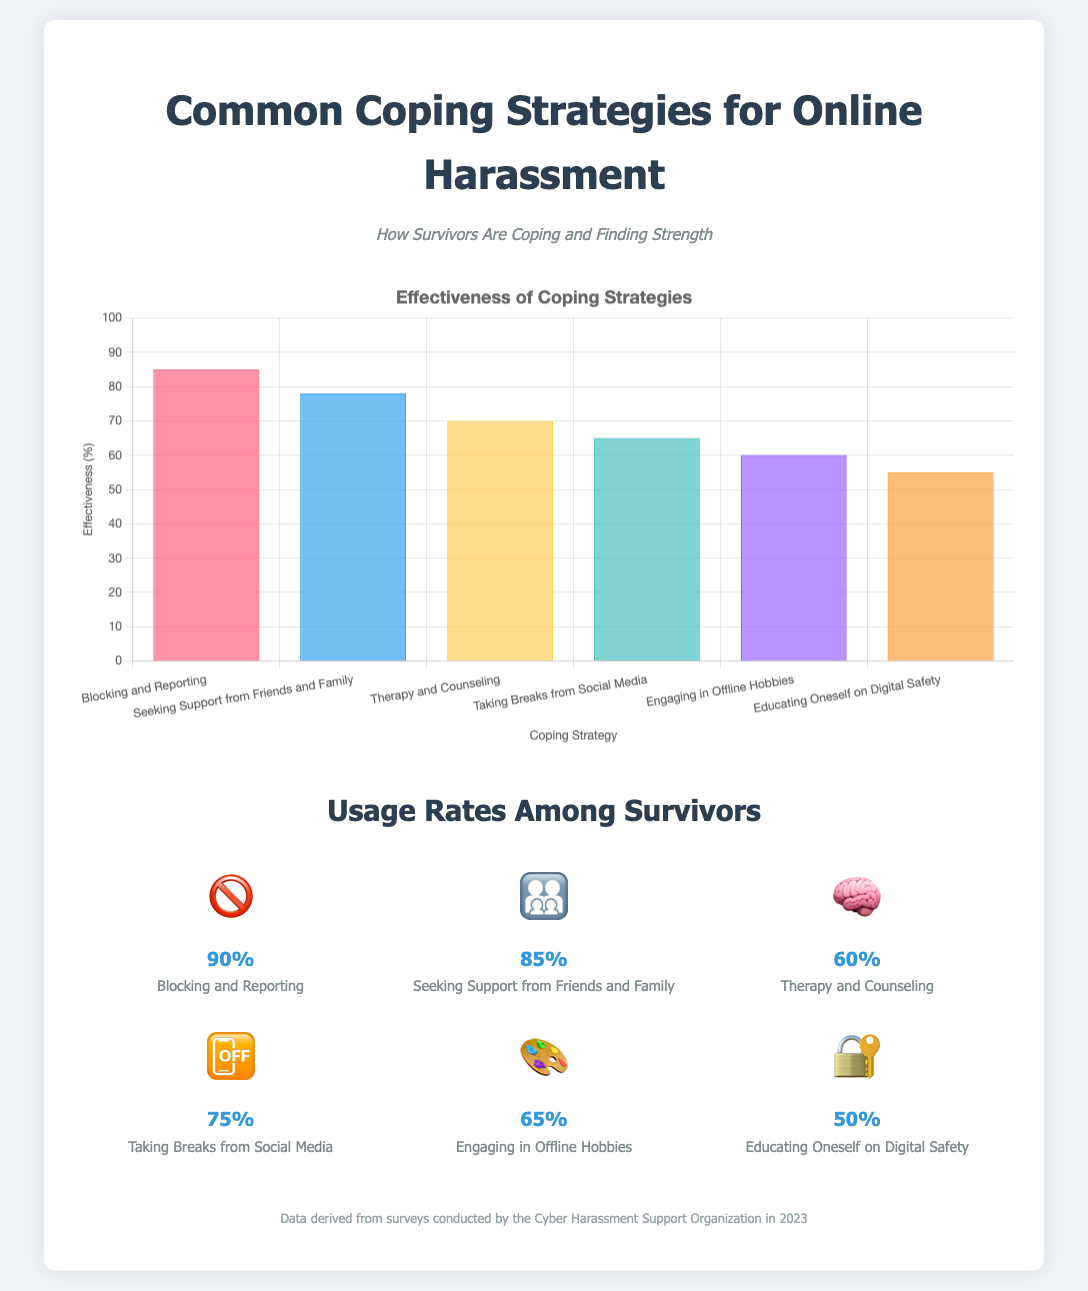What is the most effective coping strategy? The most effective coping strategy is the one with the highest percentage in the effectiveness chart, which is Blocking and Reporting at 85%.
Answer: Blocking and Reporting What percentage of survivors takes breaks from social media? The percentage of survivors who take breaks from social media is shown in the usage rates section, which states 75%.
Answer: 75% Which coping strategy has the lowest effectiveness rating? The lowest effectiveness rating is determined from the effectiveness chart, which indicates Educating Oneself on Digital Safety at 55%.
Answer: Educating Oneself on Digital Safety How many survivors seek support from friends and family? The usage rate for seeking support from friends and family is provided in the document, which is 85%.
Answer: 85% What is the title of the infographic? The title is the main heading displayed at the top of the document. In this case, it is "Common Coping Strategies for Online Harassment."
Answer: Common Coping Strategies for Online Harassment What is the source of the data presented? The source is stated at the bottom of the document, indicating who conducted the surveys. The source is the "Cyber Harassment Support Organization in 2023."
Answer: Cyber Harassment Support Organization in 2023 What is the effectiveness percentage of Therapy and Counseling? The effectiveness percentage for Therapy and Counseling is provided in the effectiveness chart, which shows 70%.
Answer: 70% What is the visual representation used for coping strategies effectiveness? The document uses a bar chart as the visual representation for coping strategies effectiveness.
Answer: Bar chart 